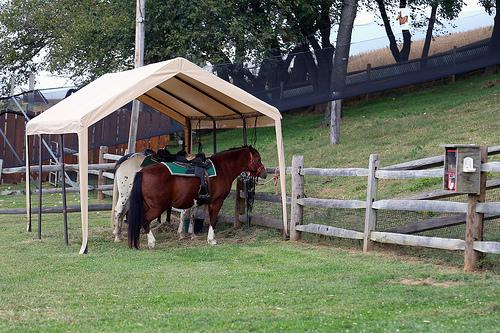Question: what color are the horses?
Choices:
A. Black.
B. Grey.
C. Green.
D. Brown and white.
Answer with the letter. Answer: D Question: what color is the fence?
Choices:
A. Red.
B. White.
C. Blue.
D. Brown.
Answer with the letter. Answer: D Question: how many horses are there?
Choices:
A. 4.
B. 5.
C. 2.
D. 6.
Answer with the letter. Answer: C Question: what are the horses standing on?
Choices:
A. Cement.
B. Grass.
C. Pavement.
D. Gravel.
Answer with the letter. Answer: B 